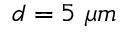<formula> <loc_0><loc_0><loc_500><loc_500>d = 5 \mu m</formula> 